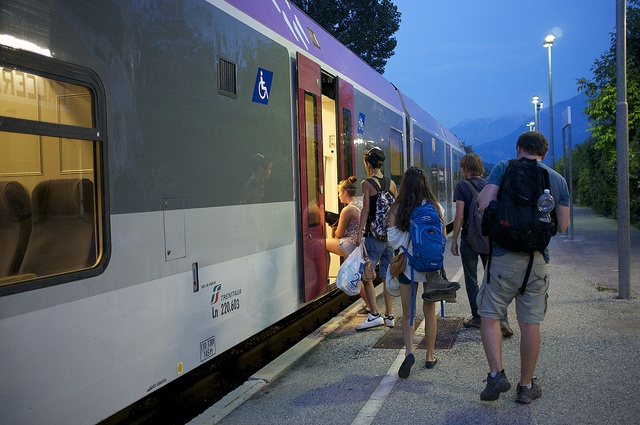Describe the objects in this image and their specific colors. I can see train in black, purple, darkgray, and darkblue tones, people in black, gray, darkblue, and navy tones, people in black, navy, and gray tones, backpack in black, navy, gray, and darkblue tones, and people in black, gray, navy, and maroon tones in this image. 